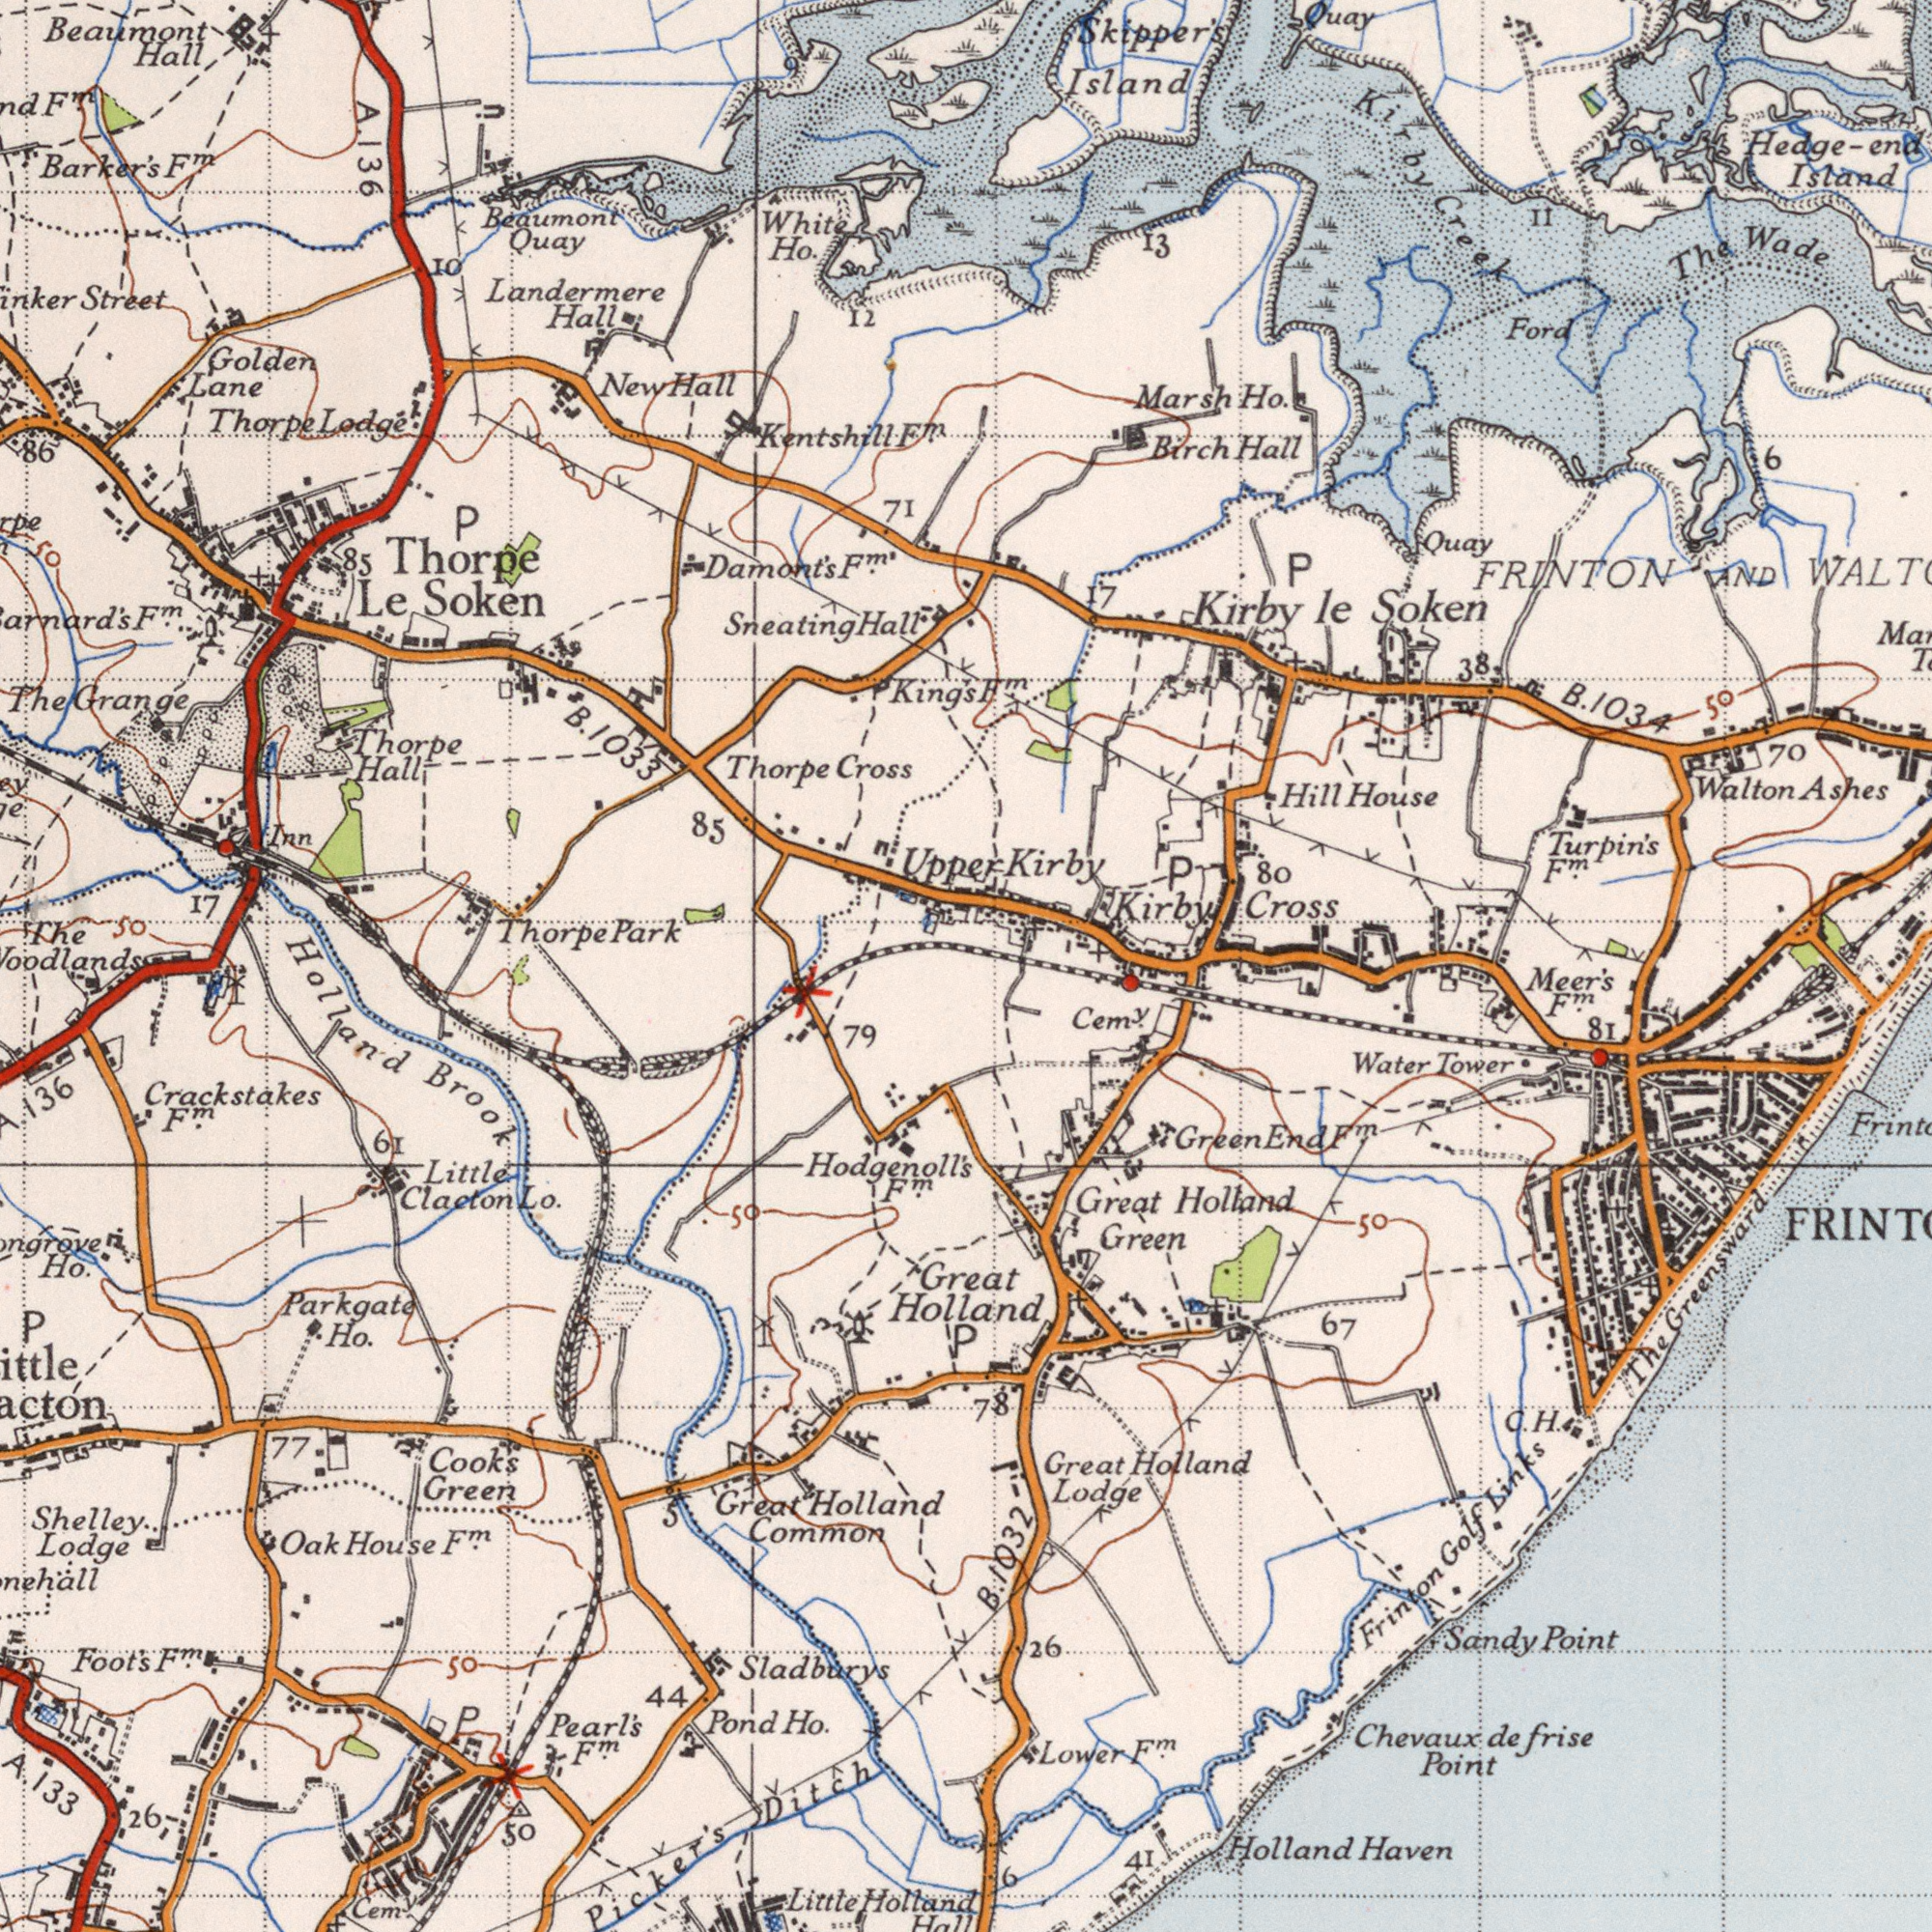What text is shown in the bottom-right quadrant? Holland Holland Haven Holland Point Great Point Great Greensward Lodge Cem<sup>y</sup>. 67 The frise Meer's Lower 41 81 Sandy F<sup>m</sup>. de 78 Chevaux 6 F<sup>m</sup>. 50 26 Green Green End F<sup>m</sup>. Water Tower Great Holland C. H. Frinton Golf Links B. 1032 What text can you see in the bottom-left section? Brook Holland Hodgenoll's Sladburys Lodge House Little Great Parkgate Cooks Oak Shelley Pearl's Green Crackstakes Ho. Cem Pond Ho. Holland Ho. 79 44 F<sup>m</sup>. 77 Common 61 F<sup>m</sup>. P F<sup>m</sup>. Foot's 50 50 50 26 F<sup>m</sup>. F<sup>m</sup>. Holland 136 A. Little Clacton Lo. P 5 P A. 133 Picker's Ditch Hall What text appears in the top-right area of the image? Walton Cross FRINTON Island Wade Ashes Creek Kirby Soken AND Birch le Marsh Kirby Skipper's The House Ford Hill Hall Ho. Quay Quay 11 80 P Island 13 F<sup>m</sup>. Hedge-end 50 P 38 17 6 70 Turpin's Kirby F<sup>m</sup>. B. 1034 Kirby What text is visible in the upper-left corner? Barker's Beaumont Thorpe Street Ho. Cross Beaumont Hall Grange Golden Quay Lane Inn Lodge Hall 17 Thorpe Landermere 85 The 50 71 12 10 New Sneating The Hall 86 50 Park Hall Hall Thorpe White F<sup>m</sup>. Thorpe F<sup>m</sup>. 9 F<sup>m</sup>. A. 136 85 p Thorpe Le Soken Damont's F<sup>m'</sup>. Kentshill F<sup>m</sup>. B. 1033 King's Upper 